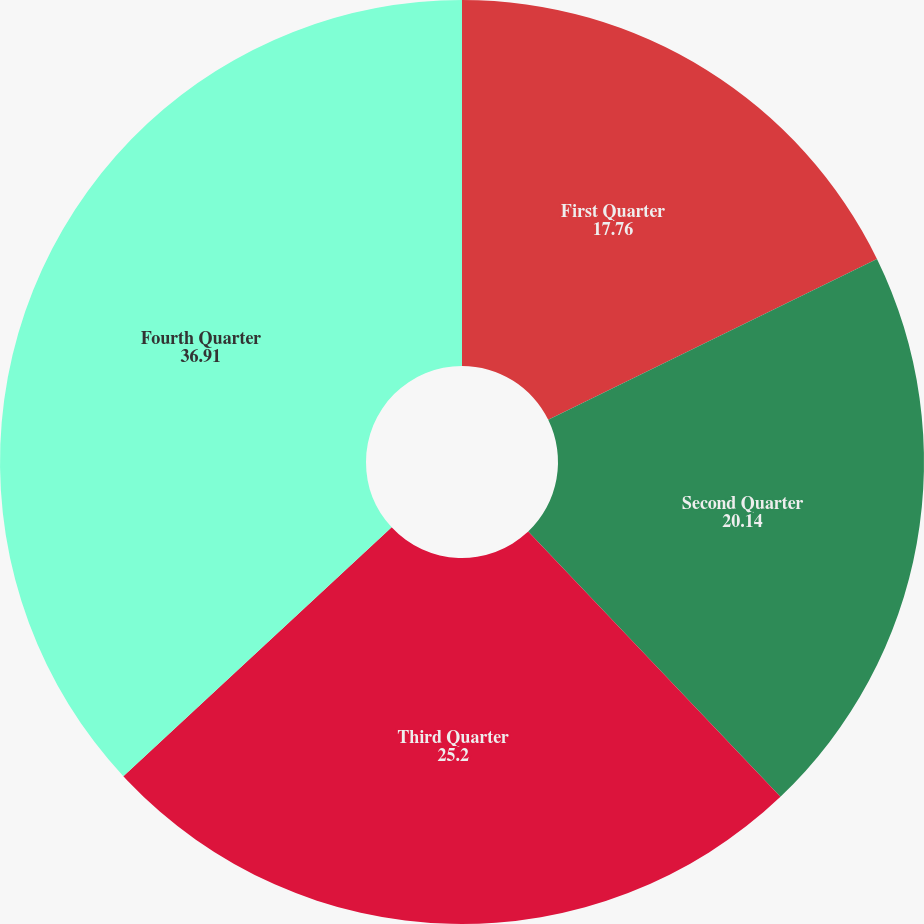Convert chart to OTSL. <chart><loc_0><loc_0><loc_500><loc_500><pie_chart><fcel>First Quarter<fcel>Second Quarter<fcel>Third Quarter<fcel>Fourth Quarter<nl><fcel>17.76%<fcel>20.14%<fcel>25.2%<fcel>36.91%<nl></chart> 